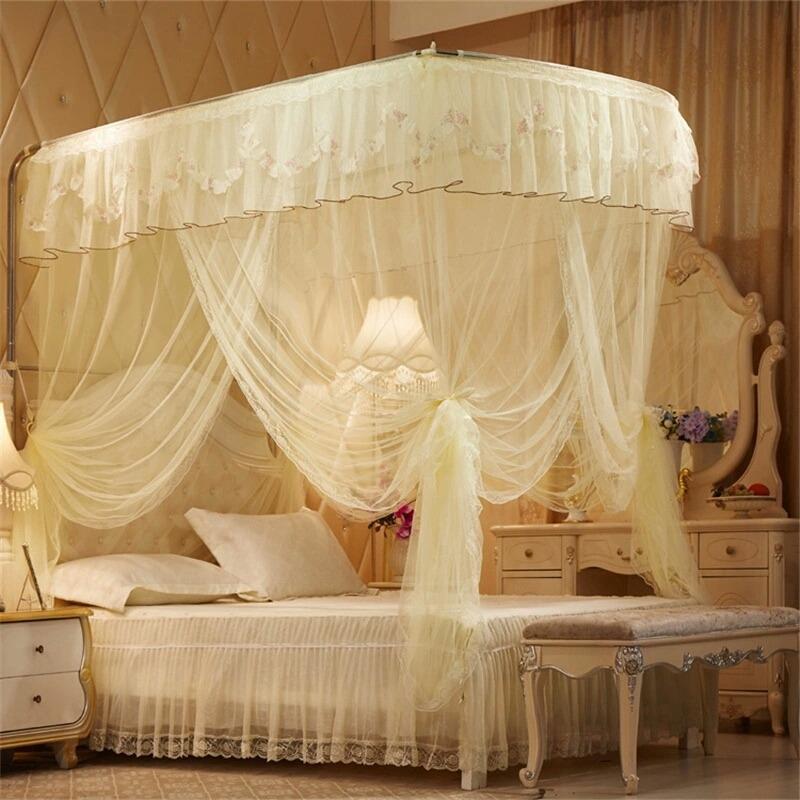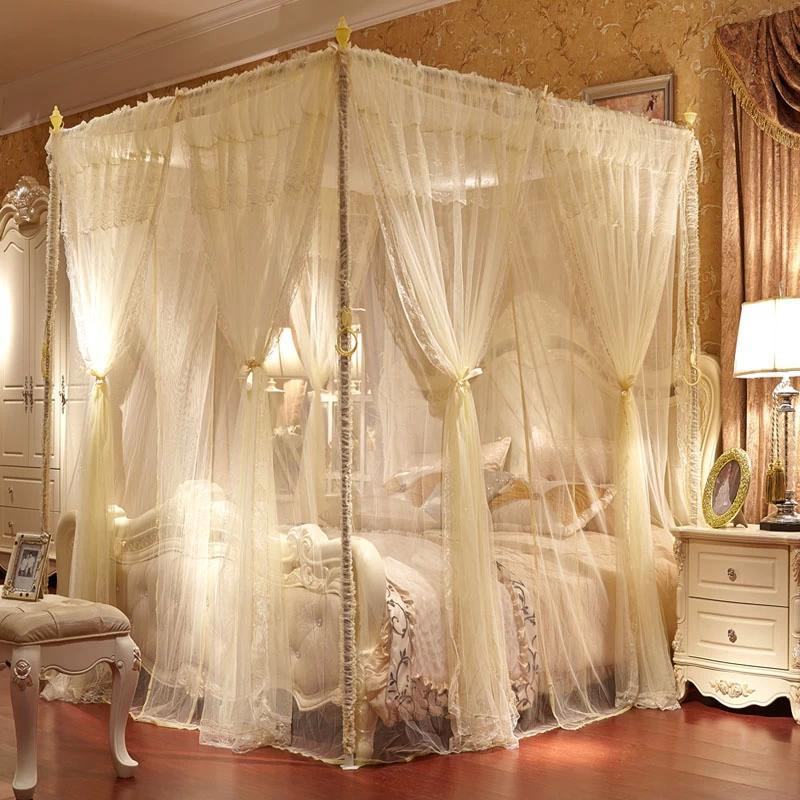The first image is the image on the left, the second image is the image on the right. Given the left and right images, does the statement "Exactly one canopy is attached to the ceiling." hold true? Answer yes or no. No. The first image is the image on the left, the second image is the image on the right. Assess this claim about the two images: "There are two white canopies; one hanging from the ceiling and the other mounted on the back wall.". Correct or not? Answer yes or no. No. 